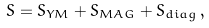<formula> <loc_0><loc_0><loc_500><loc_500>S = S _ { Y M } + S _ { M A G } + S _ { d i a g } \, ,</formula> 